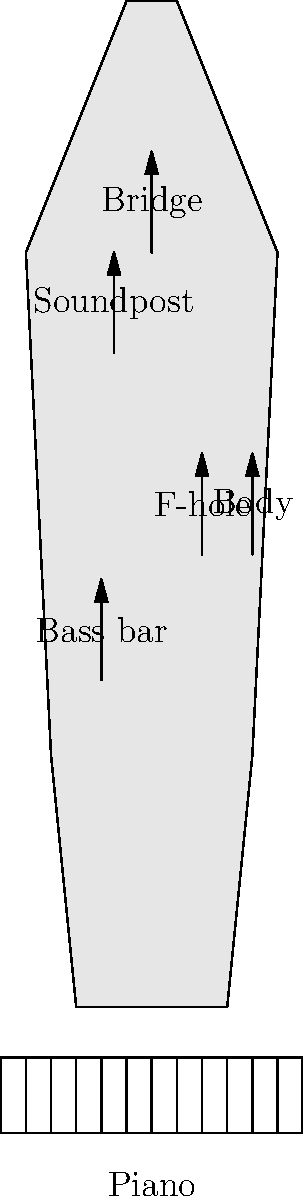In the diagram above, which part of the cello is most responsible for transmitting string vibrations to the body, and how does its function compare to the role of the soundboard in a piano? To answer this question, let's break down the acoustic properties of the cello and compare them to the piano:

1. The bridge of the cello is the primary component responsible for transmitting string vibrations to the body. It acts as a mediator between the strings and the cello's body.

2. The bridge's function in a cello is similar to the role of the bridge in a piano, but with some key differences:
   a. In a cello, the bridge stands upright and is held in place by the tension of the strings.
   b. In a piano, the bridge is a long horizontal bar attached to the soundboard.

3. The cello's body amplifies the vibrations transmitted by the bridge. This is analogous to the piano's soundboard, which amplifies the vibrations of the strings.

4. The f-holes in the cello allow air to move in and out of the body, enhancing the instrument's resonance. Pianos don't have f-holes, but the soundboard's large surface area serves a similar purpose in projecting sound.

5. The soundpost in the cello (visible in the diagram) helps transmit vibrations between the top and back plates of the instrument. This component is unique to bowed string instruments and doesn't have a direct equivalent in pianos.

6. The bass bar in the cello (also shown in the diagram) helps distribute vibrations along the length of the instrument. In a piano, this function is partially served by the metal frame and the arrangement of the strings.

7. In both instruments, the wood quality and construction of the body/soundboard significantly affect the tone and resonance.

The key similarity is that both the cello's bridge and the piano's soundboard serve to transmit and amplify string vibrations, but they do so in different ways due to the instruments' distinct designs and playing techniques.
Answer: The bridge; it transmits string vibrations to the body, similar to how a piano's soundboard amplifies string vibrations, but with distinct structural differences. 